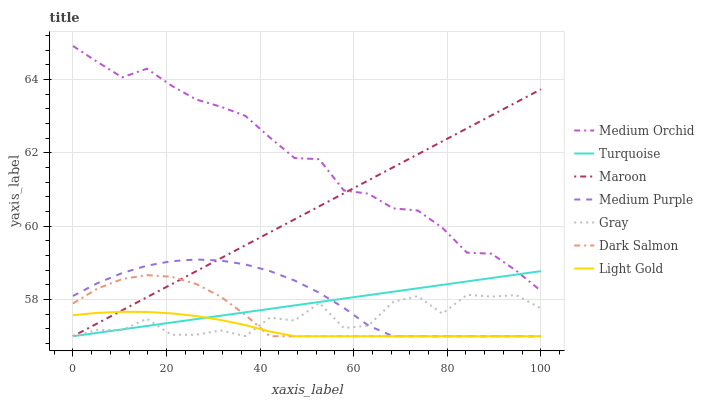Does Light Gold have the minimum area under the curve?
Answer yes or no. Yes. Does Medium Orchid have the maximum area under the curve?
Answer yes or no. Yes. Does Turquoise have the minimum area under the curve?
Answer yes or no. No. Does Turquoise have the maximum area under the curve?
Answer yes or no. No. Is Maroon the smoothest?
Answer yes or no. Yes. Is Gray the roughest?
Answer yes or no. Yes. Is Turquoise the smoothest?
Answer yes or no. No. Is Turquoise the roughest?
Answer yes or no. No. Does Gray have the lowest value?
Answer yes or no. Yes. Does Medium Orchid have the lowest value?
Answer yes or no. No. Does Medium Orchid have the highest value?
Answer yes or no. Yes. Does Turquoise have the highest value?
Answer yes or no. No. Is Dark Salmon less than Medium Orchid?
Answer yes or no. Yes. Is Medium Orchid greater than Light Gold?
Answer yes or no. Yes. Does Light Gold intersect Dark Salmon?
Answer yes or no. Yes. Is Light Gold less than Dark Salmon?
Answer yes or no. No. Is Light Gold greater than Dark Salmon?
Answer yes or no. No. Does Dark Salmon intersect Medium Orchid?
Answer yes or no. No. 